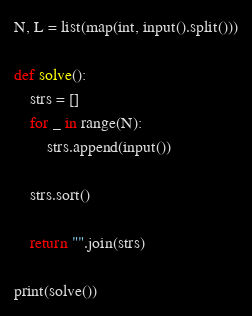Convert code to text. <code><loc_0><loc_0><loc_500><loc_500><_Python_>N, L = list(map(int, input().split()))

def solve():
    strs = []
    for _ in range(N):
        strs.append(input())

    strs.sort()

    return "".join(strs)

print(solve())
</code> 